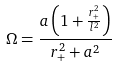<formula> <loc_0><loc_0><loc_500><loc_500>\Omega = \frac { a \left ( 1 + \frac { r _ { + } ^ { 2 } } { l ^ { 2 } } \right ) } { r _ { + } ^ { 2 } + a ^ { 2 } }</formula> 